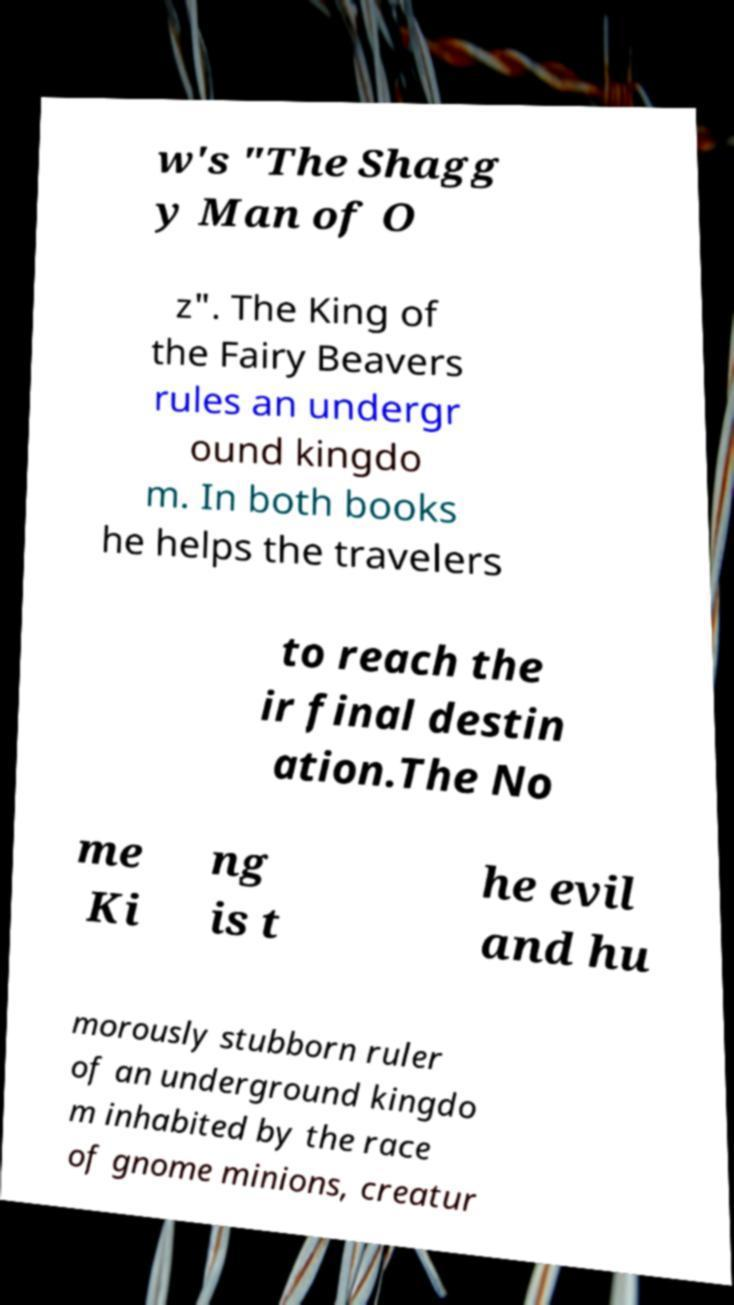For documentation purposes, I need the text within this image transcribed. Could you provide that? w's "The Shagg y Man of O z". The King of the Fairy Beavers rules an undergr ound kingdo m. In both books he helps the travelers to reach the ir final destin ation.The No me Ki ng is t he evil and hu morously stubborn ruler of an underground kingdo m inhabited by the race of gnome minions, creatur 